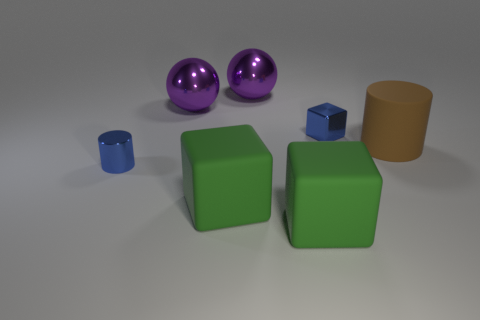What material is the small cylinder that is the same color as the small block?
Offer a very short reply. Metal. Is there a green thing that has the same size as the brown cylinder?
Your answer should be very brief. Yes. Are there more large brown cylinders left of the brown object than brown matte cylinders on the left side of the metallic cylinder?
Provide a short and direct response. No. Are the blue block that is right of the blue cylinder and the cylinder that is left of the metallic block made of the same material?
Provide a short and direct response. Yes. What is the shape of the metallic thing that is the same size as the blue cube?
Keep it short and to the point. Cylinder. Are there any large blue metal objects of the same shape as the brown rubber thing?
Ensure brevity in your answer.  No. Is the color of the large rubber thing that is right of the blue block the same as the tiny metallic object that is behind the large brown rubber cylinder?
Provide a succinct answer. No. There is a matte cylinder; are there any big metallic objects in front of it?
Your answer should be very brief. No. There is a thing that is in front of the metal block and behind the blue cylinder; what material is it made of?
Ensure brevity in your answer.  Rubber. Are the blue thing behind the shiny cylinder and the brown cylinder made of the same material?
Make the answer very short. No. 